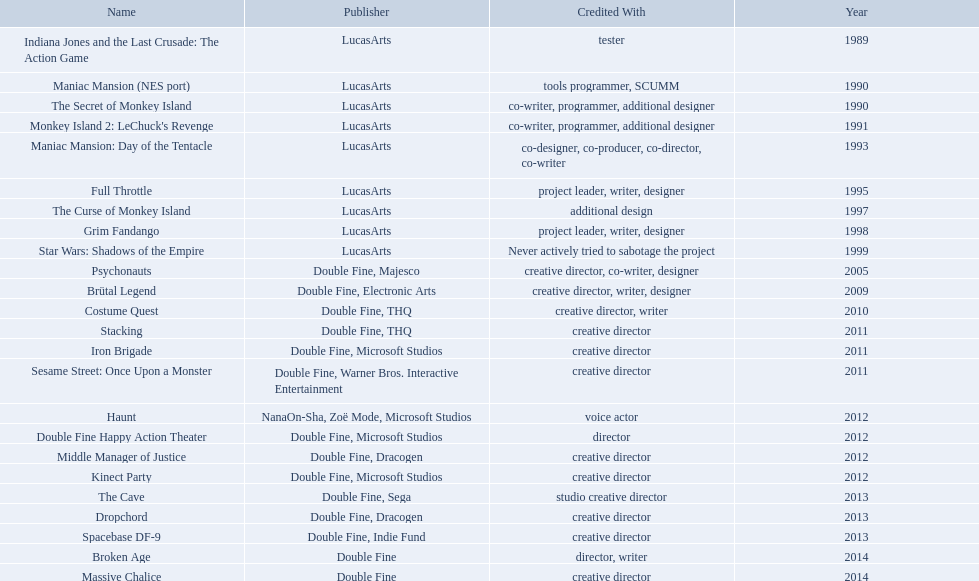Which productions did tim schafer work on that were published in part by double fine? Psychonauts, Brütal Legend, Costume Quest, Stacking, Iron Brigade, Sesame Street: Once Upon a Monster, Double Fine Happy Action Theater, Middle Manager of Justice, Kinect Party, The Cave, Dropchord, Spacebase DF-9, Broken Age, Massive Chalice. Which of these was he a creative director? Psychonauts, Brütal Legend, Costume Quest, Stacking, Iron Brigade, Sesame Street: Once Upon a Monster, Middle Manager of Justice, Kinect Party, The Cave, Dropchord, Spacebase DF-9, Massive Chalice. Which of those were in 2011? Stacking, Iron Brigade, Sesame Street: Once Upon a Monster. What was the only one of these to be co published by warner brothers? Sesame Street: Once Upon a Monster. 